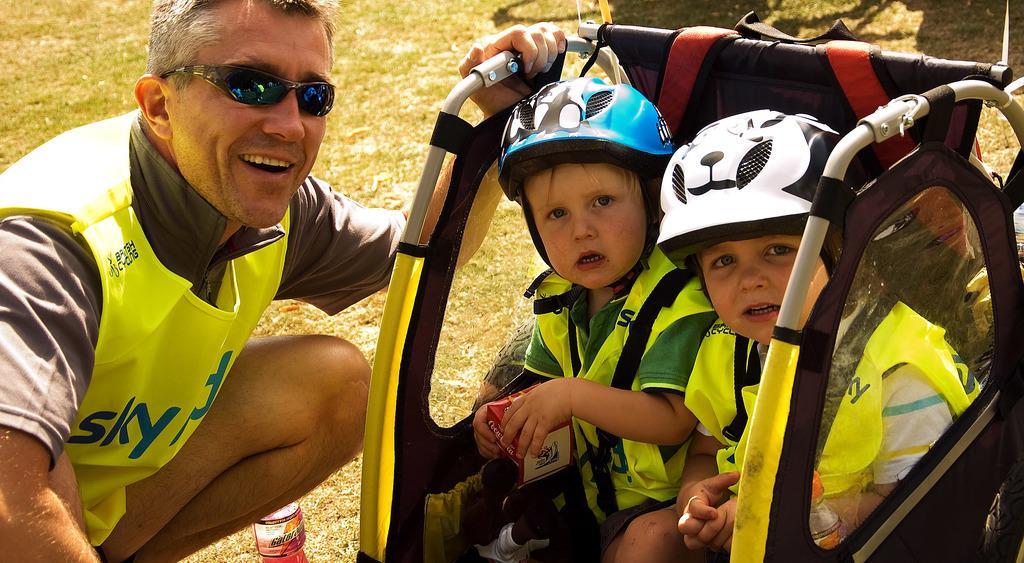Could you give a brief overview of what you see in this image? In this image I can see three people with dresses and two people wearing the helmets. I can see two people sitting on an object and it looks like the stroller. 